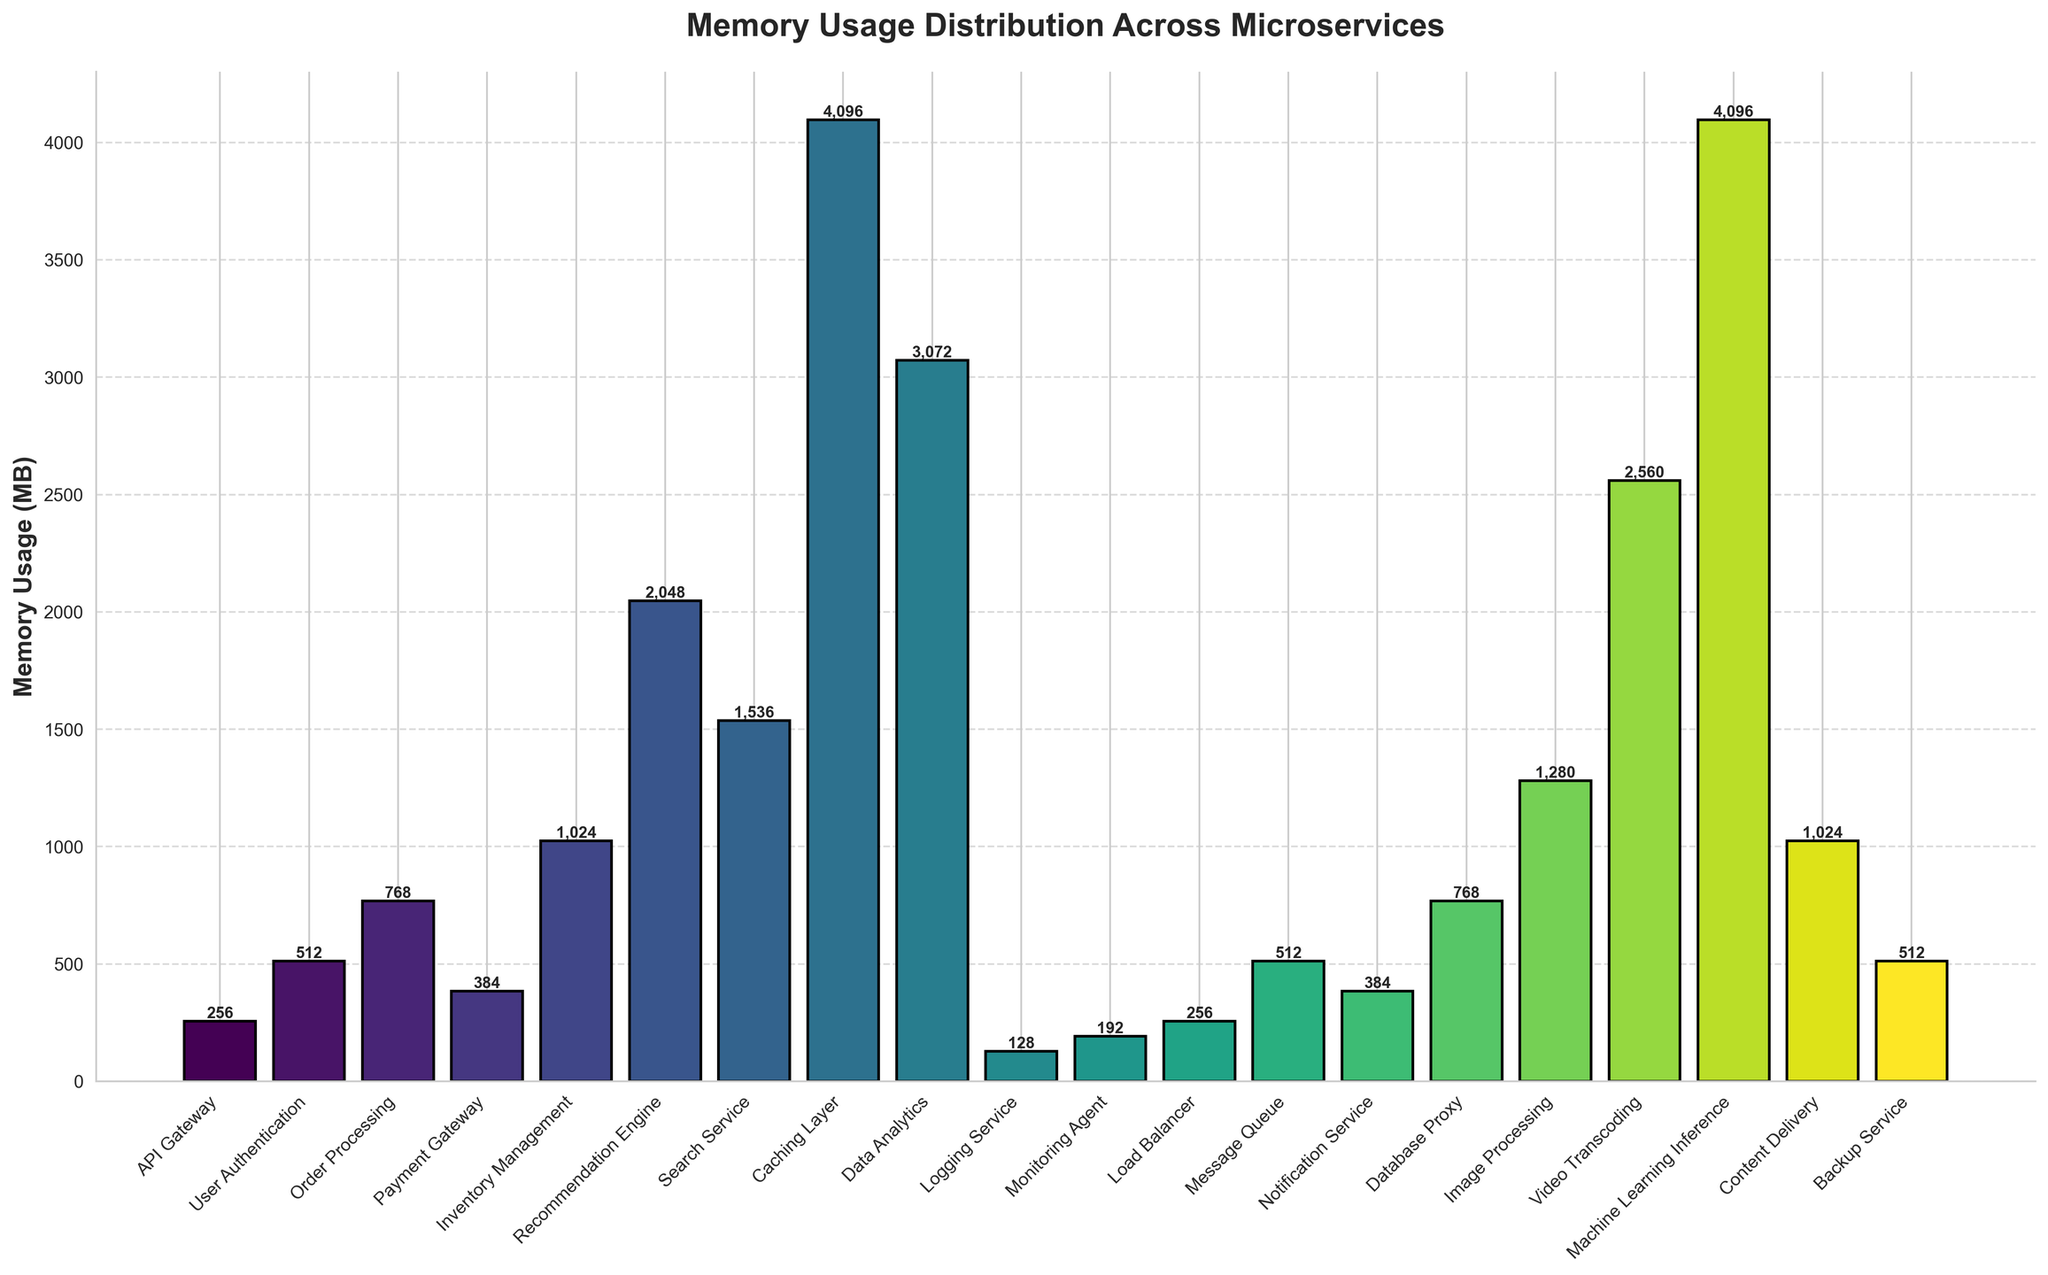How many services use more than 1000 MB of memory? Identify the bars that extend above the 1000 MB mark and count them. There are 6 such services: Inventory Management, Recommendation Engine, Search Service, Data Analytics, Image Processing, and Video Transcoding.
Answer: 6 What is the total memory usage of the services related to data handling (Data Analytics, Logging Service, and Backup Service)? Add the memory usage of Data Analytics (3072 MB), Logging Service (128 MB), and Backup Service (512 MB). The sum is 3072 + 128 + 512 = 3712 MB.
Answer: 3712 MB Which service uses the least memory and how much does it use? Identify the bar with the smallest height. The Logging Service has the shortest bar with a memory usage of 128 MB.
Answer: Logging Service, 128 MB How much more memory does the Recommendation Engine use compared to the Payment Gateway? Subtract the memory usage of the Payment Gateway (384 MB) from the memory usage of the Recommendation Engine (2048 MB). The difference is 2048 - 384 = 1664 MB.
Answer: 1664 MB Which service has the highest memory usage and what is the value? Identify the bar with the highest height. The Machine Learning Inference and the Caching Layer both have the highest bars with a memory usage of 4096 MB each.
Answer: Machine Learning Inference and Caching Layer, 4096 MB What is the average memory usage across all services? Sum the memory usage of all the services and divide by the number of services. Total memory usage is 31232 MB across 20 services. Average is 31232 / 20 = 1561.6 MB.
Answer: 1561.6 MB Are there any services that use exactly 512 MB of memory? If so, which ones? Identify the bars that are exactly at the 512 MB mark. There are User Authentication, Message Queue, and Backup Service.
Answer: User Authentication, Message Queue, Backup Service Compare the memory usage of Order Processing and Message Queue. Which one uses more memory and by how much? Order Processing uses 768 MB while Message Queue uses 512 MB. The difference is 768 - 512 = 256 MB. Order Processing uses 256 MB more memory than Message Queue.
Answer: Order Processing, 256 MB 